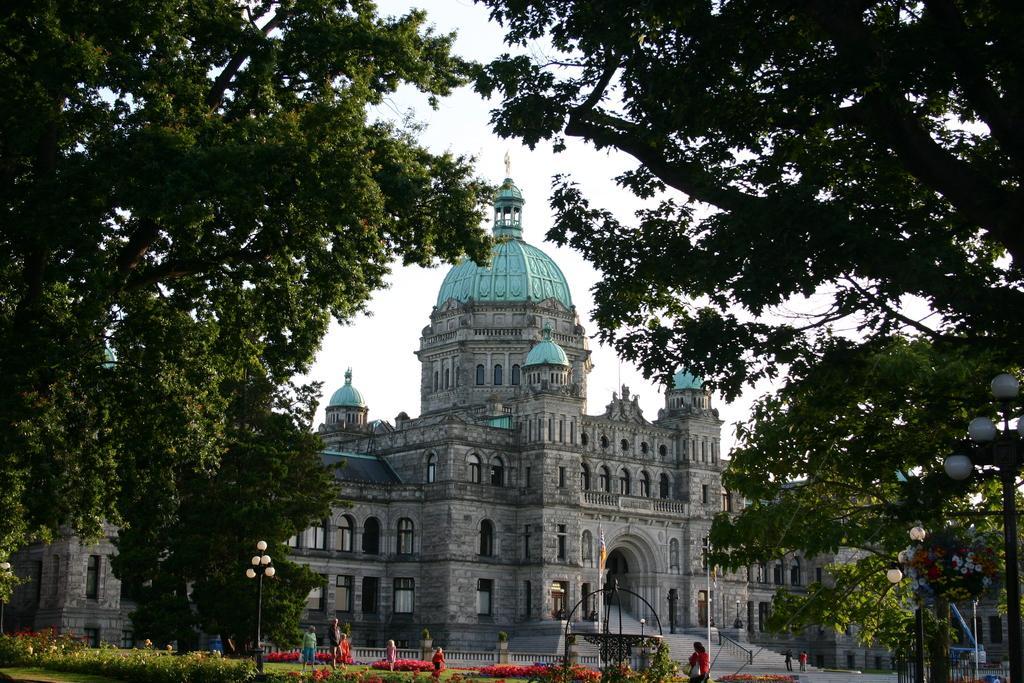Please provide a concise description of this image. In this image I can see number of trees, a building, stairs, plants, flowers, few poles, a flag, few lights and I can see number of people are standing. I can also see few more lights and few more poles over here. 